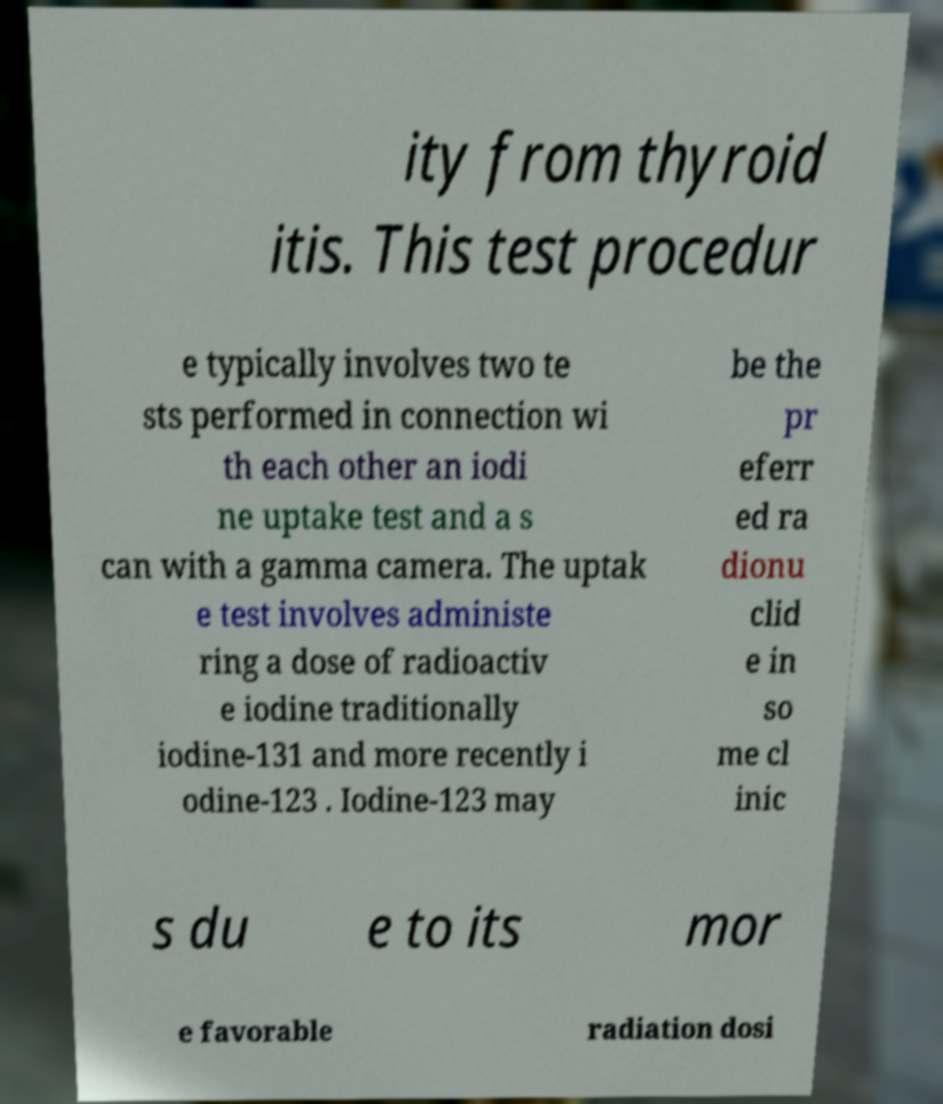For documentation purposes, I need the text within this image transcribed. Could you provide that? ity from thyroid itis. This test procedur e typically involves two te sts performed in connection wi th each other an iodi ne uptake test and a s can with a gamma camera. The uptak e test involves administe ring a dose of radioactiv e iodine traditionally iodine-131 and more recently i odine-123 . Iodine-123 may be the pr eferr ed ra dionu clid e in so me cl inic s du e to its mor e favorable radiation dosi 